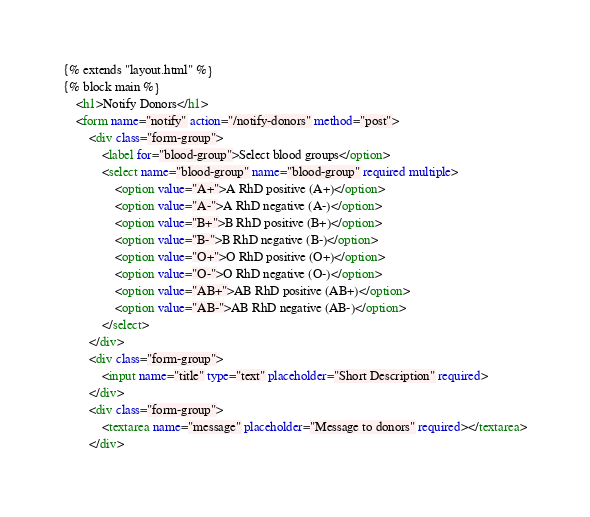<code> <loc_0><loc_0><loc_500><loc_500><_HTML_>{% extends "layout.html" %}
{% block main %}
    <h1>Notify Donors</h1>
    <form name="notify" action="/notify-donors" method="post">
        <div class="form-group">
            <label for="blood-group">Select blood groups</option>
            <select name="blood-group" name="blood-group" required multiple>
                <option value="A+">A RhD positive (A+)</option>
                <option value="A-">A RhD negative (A-)</option>
                <option value="B+">B RhD positive (B+)</option>
                <option value="B-">B RhD negative (B-)</option>
                <option value="O+">O RhD positive (O+)</option>
                <option value="O-">O RhD negative (O-)</option>
                <option value="AB+">AB RhD positive (AB+)</option>
                <option value="AB-">AB RhD negative (AB-)</option>
            </select>
        </div>
        <div class="form-group">
            <input name="title" type="text" placeholder="Short Description" required>
        </div>
        <div class="form-group">
            <textarea name="message" placeholder="Message to donors" required></textarea>
        </div></code> 